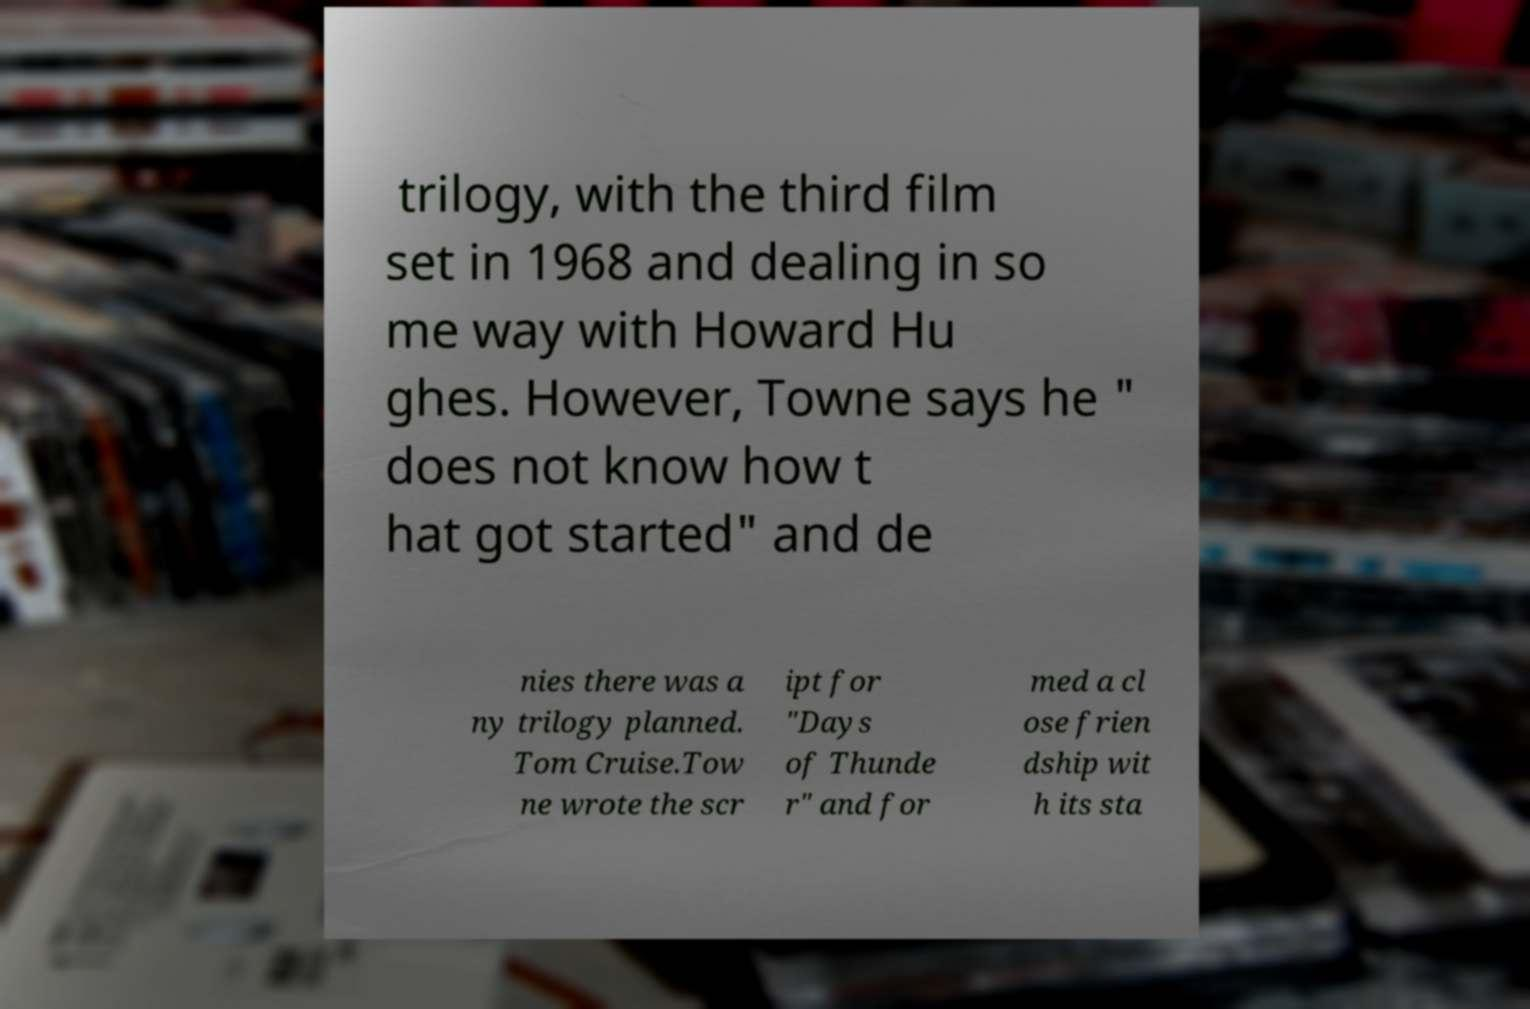There's text embedded in this image that I need extracted. Can you transcribe it verbatim? trilogy, with the third film set in 1968 and dealing in so me way with Howard Hu ghes. However, Towne says he " does not know how t hat got started" and de nies there was a ny trilogy planned. Tom Cruise.Tow ne wrote the scr ipt for "Days of Thunde r" and for med a cl ose frien dship wit h its sta 